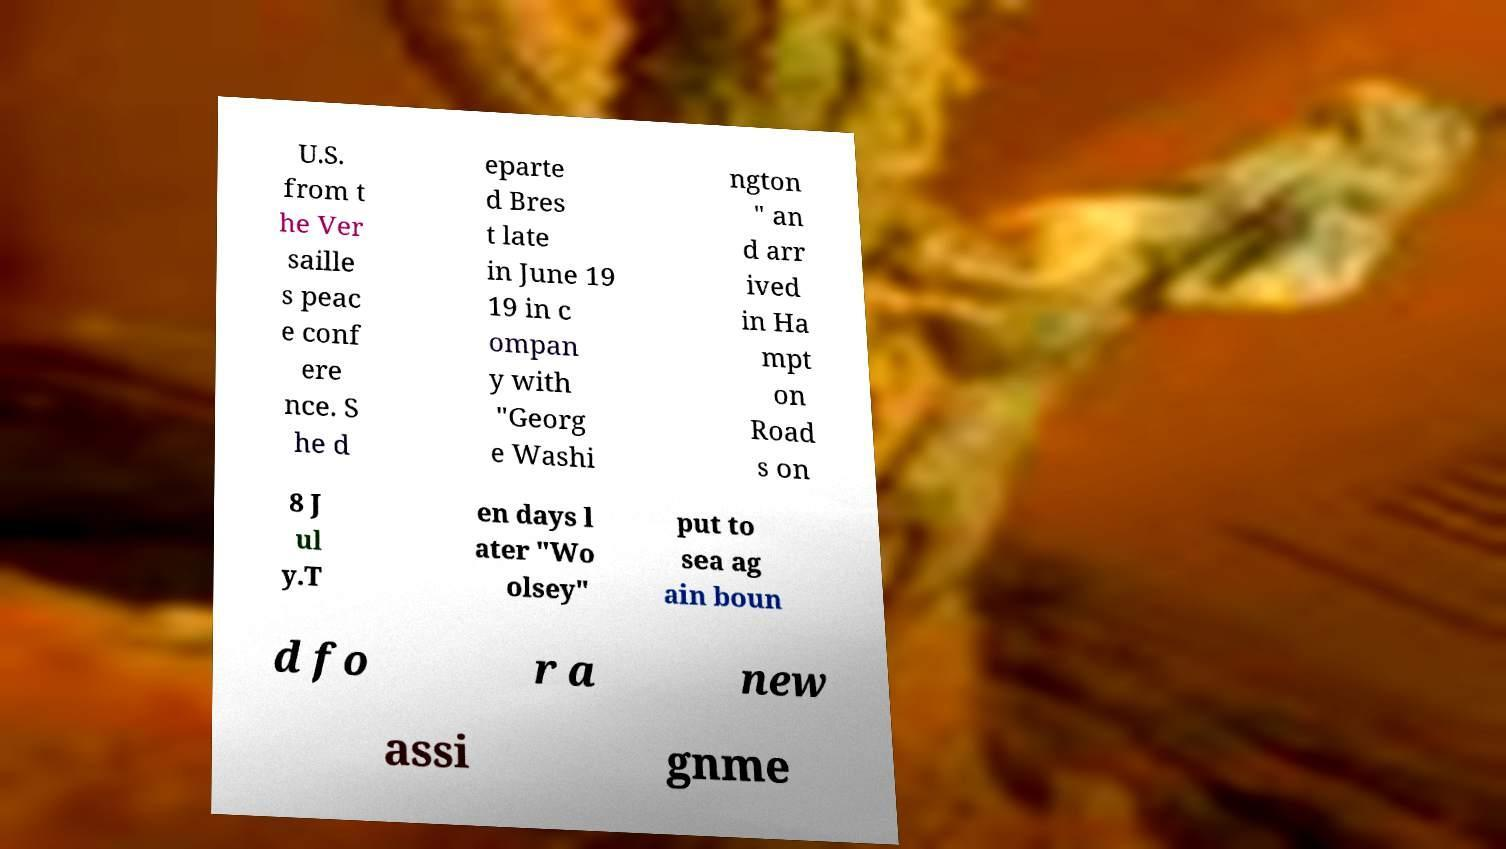What messages or text are displayed in this image? I need them in a readable, typed format. U.S. from t he Ver saille s peac e conf ere nce. S he d eparte d Bres t late in June 19 19 in c ompan y with "Georg e Washi ngton " an d arr ived in Ha mpt on Road s on 8 J ul y.T en days l ater "Wo olsey" put to sea ag ain boun d fo r a new assi gnme 